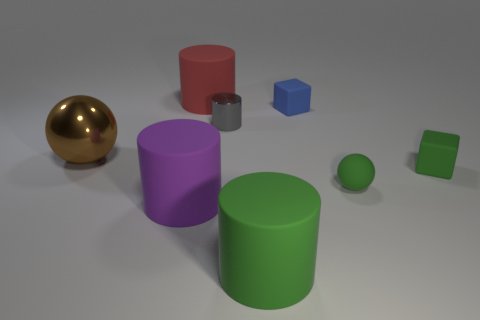Subtract all small metal cylinders. How many cylinders are left? 3 Add 2 large cylinders. How many objects exist? 10 Subtract all cubes. How many objects are left? 6 Subtract 1 cylinders. How many cylinders are left? 3 Subtract all purple cylinders. How many cylinders are left? 3 Subtract 0 yellow cubes. How many objects are left? 8 Subtract all yellow spheres. Subtract all gray blocks. How many spheres are left? 2 Subtract all purple cubes. Subtract all gray cylinders. How many objects are left? 7 Add 6 cubes. How many cubes are left? 8 Add 7 brown matte blocks. How many brown matte blocks exist? 7 